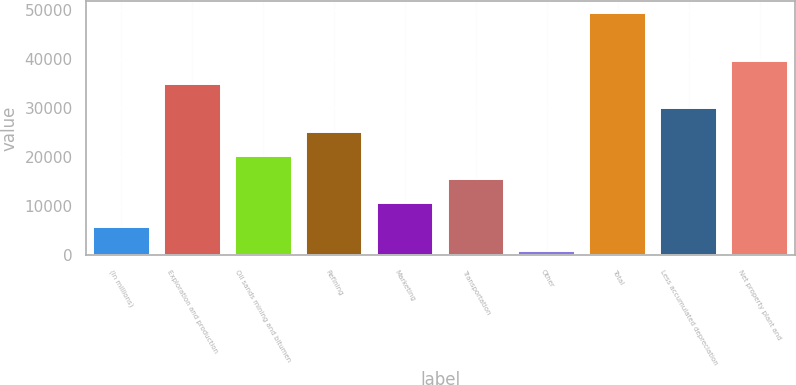<chart> <loc_0><loc_0><loc_500><loc_500><bar_chart><fcel>(In millions)<fcel>Exploration and production<fcel>Oil sands mining and bitumen<fcel>Refining<fcel>Marketing<fcel>Transportation<fcel>Other<fcel>Total<fcel>Less accumulated depreciation<fcel>Net property plant and<nl><fcel>5787.4<fcel>34799.8<fcel>20293.6<fcel>25129<fcel>10622.8<fcel>15458.2<fcel>952<fcel>49306<fcel>29964.4<fcel>39635.2<nl></chart> 